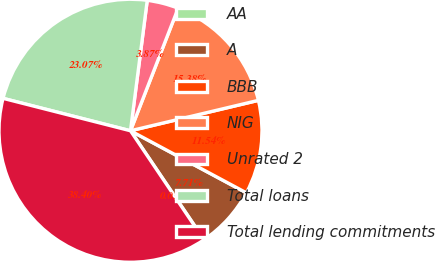Convert chart to OTSL. <chart><loc_0><loc_0><loc_500><loc_500><pie_chart><fcel>AA<fcel>A<fcel>BBB<fcel>NIG<fcel>Unrated 2<fcel>Total loans<fcel>Total lending commitments<nl><fcel>0.03%<fcel>7.71%<fcel>11.54%<fcel>15.38%<fcel>3.87%<fcel>23.07%<fcel>38.4%<nl></chart> 